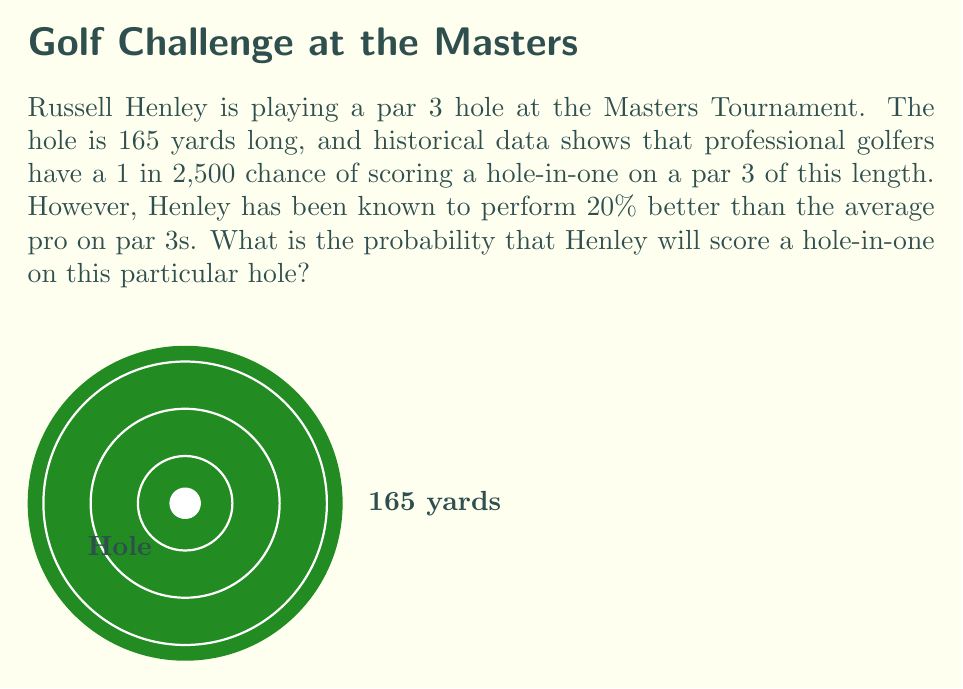Show me your answer to this math problem. Let's approach this step-by-step:

1) First, we need to understand the given information:
   - The average probability of a hole-in-one for pros is 1 in 2,500, or $\frac{1}{2500}$.
   - Henley performs 20% better than average on par 3s.

2) To calculate Henley's improved probability, we need to increase the average probability by 20%:
   
   Let $x$ be Henley's probability.
   
   $x = \frac{1}{2500} + 20\% \cdot \frac{1}{2500}$

3) We can calculate 20% of $\frac{1}{2500}$:
   
   $20\% \cdot \frac{1}{2500} = 0.2 \cdot \frac{1}{2500} = \frac{1}{12500}$

4) Now we can add this to the original probability:

   $x = \frac{1}{2500} + \frac{1}{12500}$

5) To add these fractions, we need a common denominator:
   
   $x = \frac{5}{12500} + \frac{1}{12500} = \frac{6}{12500}$

6) This fraction can be simplified:
   
   $x = \frac{6}{12500} = \frac{3}{6250} = \frac{1}{2083.33...}$

Therefore, Henley's probability of scoring a hole-in-one on this hole is approximately $\frac{1}{2083}$ or about 0.00048.
Answer: $\frac{1}{2083}$ or approximately 0.00048 